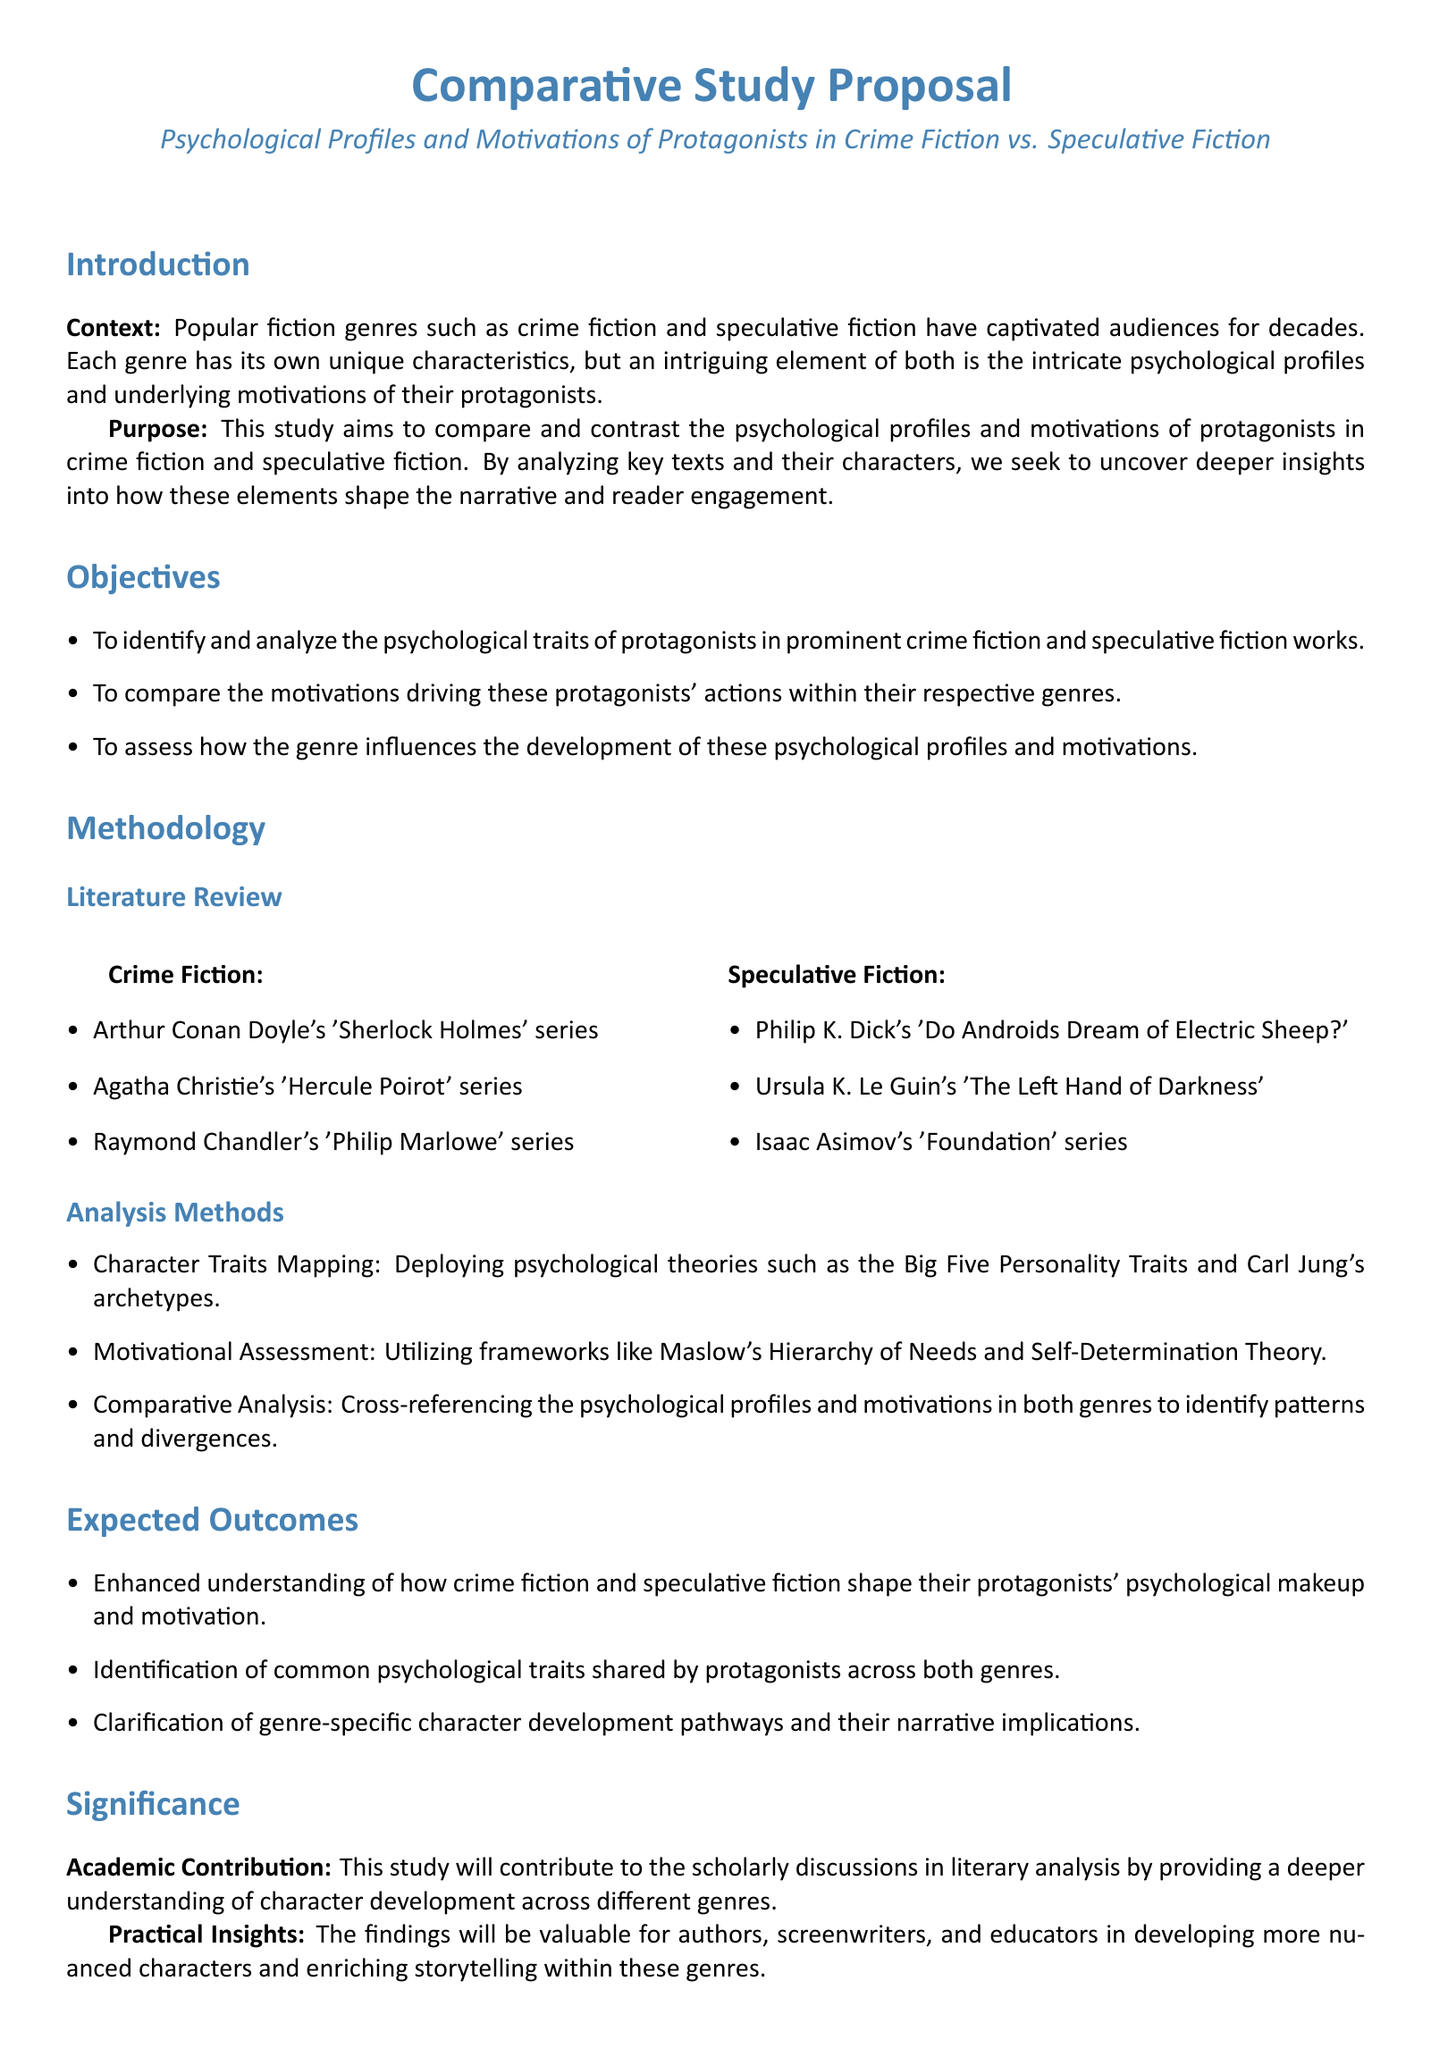what is the title of the proposal? The title of the proposal is found at the top of the document, which outlines the focus of the research.
Answer: Psychological Profiles and Motivations of Protagonists in Crime Fiction vs. Speculative Fiction how many months are allocated for the initial phase? The initial phase timeline is mentioned in the document, indicating how long the first part of the study will take.
Answer: 2 months which psychological theory is mentioned for character traits mapping? The document outlines psychological theories used for character traits mapping, highlighting the theoretical framework for analysis.
Answer: Big Five Personality Traits what are the two genres compared in the study? The introduction specifies the genres that are the focus of the comparative study.
Answer: crime fiction and speculative fiction what is one expected outcome of the study? The document lists expected outcomes, which are anticipated results from the research conducted.
Answer: Enhanced understanding of how crime fiction and speculative fiction shape their protagonists' psychological makeup and motivation how many primary texts from crime fiction are selected for analysis? The methodology section specifically lists multiple key texts under crime fiction, which indicates how many sources are included in the study.
Answer: 3 what framework is utilized for motivational assessment? The methodology section specifies the frameworks employed for understanding motivations in the characters being analyzed.
Answer: Maslow's Hierarchy of Needs what is the significance of this study for academic contribution? The document highlights the academic impact that the research aims to achieve, emphasizing its relevance to literary discussions.
Answer: Deeper understanding of character development across different genres how long is the conclusion phase for final report preparation? The timeline section describes the duration of the final phase, marking the period allocated for report completion.
Answer: 1 month 